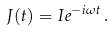<formula> <loc_0><loc_0><loc_500><loc_500>J ( t ) = I e ^ { - i \omega t } \, .</formula> 